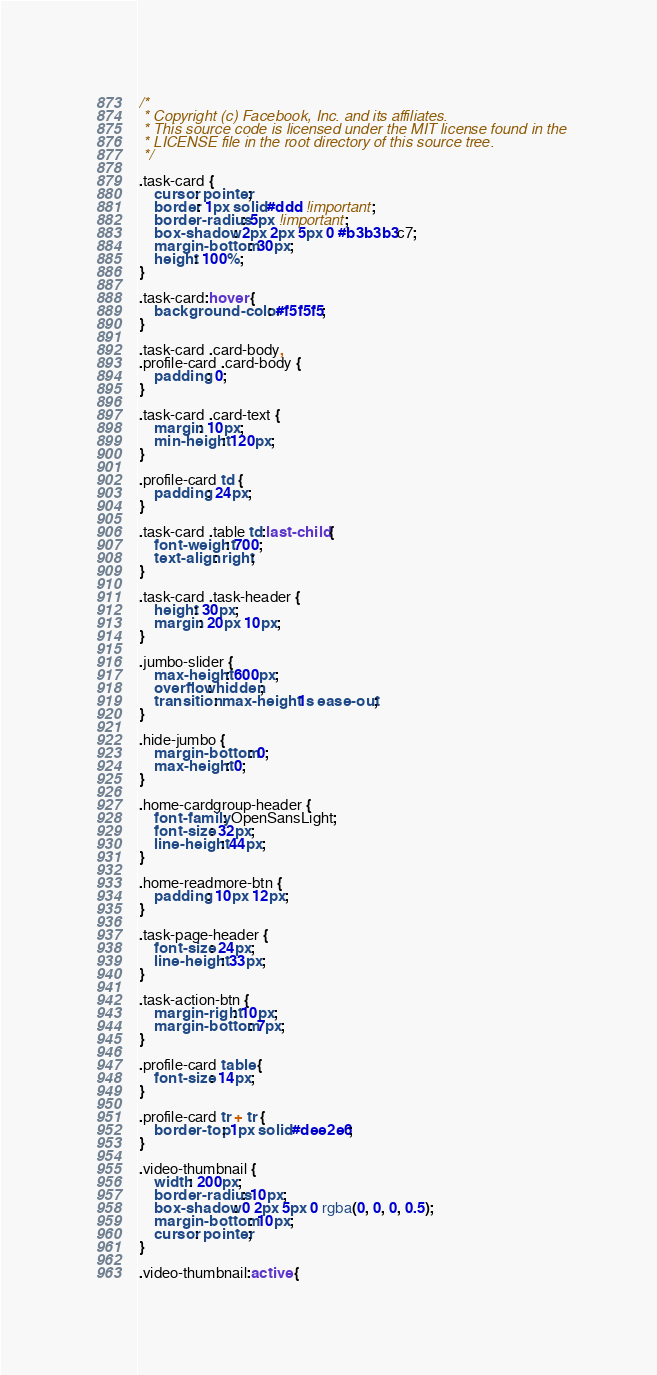<code> <loc_0><loc_0><loc_500><loc_500><_CSS_>/*
 * Copyright (c) Facebook, Inc. and its affiliates.
 * This source code is licensed under the MIT license found in the
 * LICENSE file in the root directory of this source tree.
 */

.task-card {
    cursor: pointer;
    border: 1px solid #ddd !important;
    border-radius: 5px !important;
    box-shadow: 2px 2px 5px 0 #b3b3b3c7;
    margin-bottom: 30px;
    height: 100%;
}

.task-card:hover {
    background-color: #f5f5f5;
}

.task-card .card-body,
.profile-card .card-body {
    padding: 0;
}

.task-card .card-text {
    margin: 10px;
    min-height: 120px;
}

.profile-card td {
    padding: 24px;
}

.task-card .table td:last-child {
    font-weight: 700;
    text-align: right;
}

.task-card .task-header {
    height: 30px;
    margin: 20px 10px;
}

.jumbo-slider {
    max-height: 600px;
    overflow: hidden;
    transition: max-height 1s ease-out;
}

.hide-jumbo {
    margin-bottom: 0;
    max-height: 0;
}

.home-cardgroup-header {
    font-family: OpenSansLight;
    font-size: 32px;
    line-height: 44px;
}

.home-readmore-btn {
    padding: 10px 12px;
}

.task-page-header {
    font-size: 24px;
    line-height: 33px;
}

.task-action-btn {
    margin-right: 10px;
    margin-bottom: 7px;
}

.profile-card table {
    font-size: 14px;
}

.profile-card tr + tr {
    border-top: 1px solid #dee2e6;
}

.video-thumbnail {
    width: 200px;
    border-radius: 10px;
    box-shadow: 0 2px 5px 0 rgba(0, 0, 0, 0.5);
    margin-bottom: 10px;
    cursor: pointer;
}

.video-thumbnail:active {</code> 